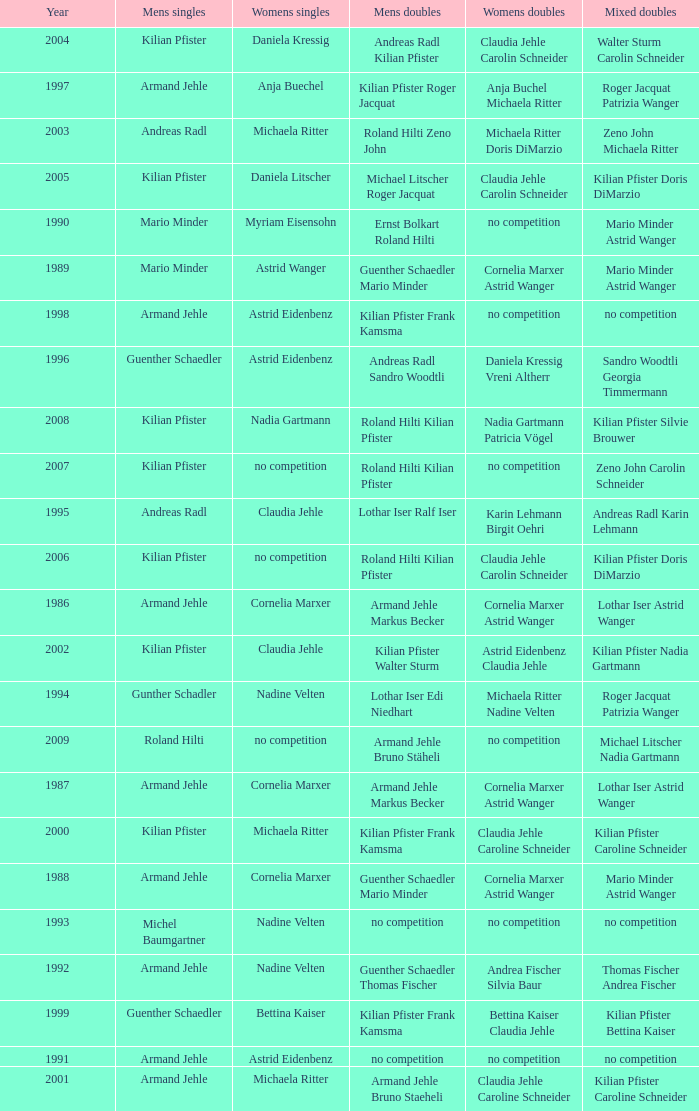In 2004, where the womens singles is daniela kressig who is the mens singles Kilian Pfister. 